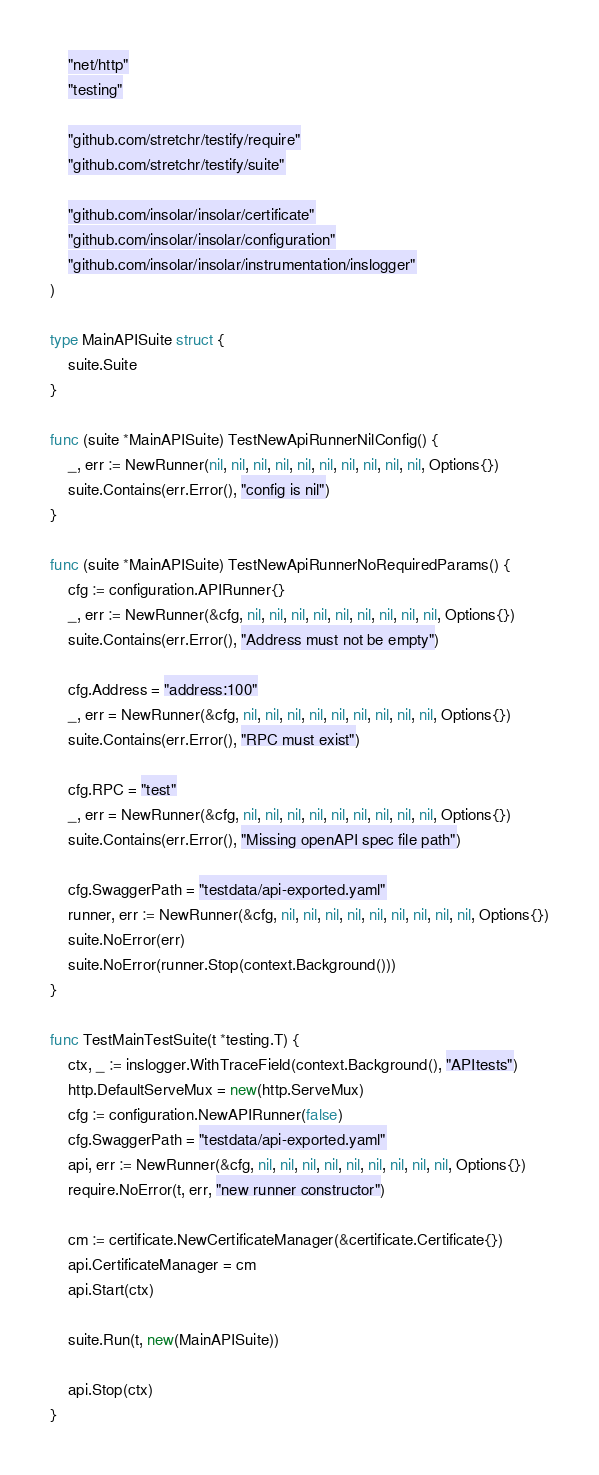Convert code to text. <code><loc_0><loc_0><loc_500><loc_500><_Go_>	"net/http"
	"testing"

	"github.com/stretchr/testify/require"
	"github.com/stretchr/testify/suite"

	"github.com/insolar/insolar/certificate"
	"github.com/insolar/insolar/configuration"
	"github.com/insolar/insolar/instrumentation/inslogger"
)

type MainAPISuite struct {
	suite.Suite
}

func (suite *MainAPISuite) TestNewApiRunnerNilConfig() {
	_, err := NewRunner(nil, nil, nil, nil, nil, nil, nil, nil, nil, nil, Options{})
	suite.Contains(err.Error(), "config is nil")
}

func (suite *MainAPISuite) TestNewApiRunnerNoRequiredParams() {
	cfg := configuration.APIRunner{}
	_, err := NewRunner(&cfg, nil, nil, nil, nil, nil, nil, nil, nil, nil, Options{})
	suite.Contains(err.Error(), "Address must not be empty")

	cfg.Address = "address:100"
	_, err = NewRunner(&cfg, nil, nil, nil, nil, nil, nil, nil, nil, nil, Options{})
	suite.Contains(err.Error(), "RPC must exist")

	cfg.RPC = "test"
	_, err = NewRunner(&cfg, nil, nil, nil, nil, nil, nil, nil, nil, nil, Options{})
	suite.Contains(err.Error(), "Missing openAPI spec file path")

	cfg.SwaggerPath = "testdata/api-exported.yaml"
	runner, err := NewRunner(&cfg, nil, nil, nil, nil, nil, nil, nil, nil, nil, Options{})
	suite.NoError(err)
	suite.NoError(runner.Stop(context.Background()))
}

func TestMainTestSuite(t *testing.T) {
	ctx, _ := inslogger.WithTraceField(context.Background(), "APItests")
	http.DefaultServeMux = new(http.ServeMux)
	cfg := configuration.NewAPIRunner(false)
	cfg.SwaggerPath = "testdata/api-exported.yaml"
	api, err := NewRunner(&cfg, nil, nil, nil, nil, nil, nil, nil, nil, nil, Options{})
	require.NoError(t, err, "new runner constructor")

	cm := certificate.NewCertificateManager(&certificate.Certificate{})
	api.CertificateManager = cm
	api.Start(ctx)

	suite.Run(t, new(MainAPISuite))

	api.Stop(ctx)
}
</code> 